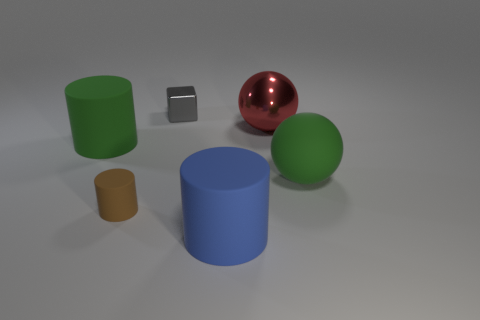Add 1 tiny gray shiny cubes. How many objects exist? 7 Subtract all blocks. How many objects are left? 5 Subtract all matte spheres. Subtract all large red metal balls. How many objects are left? 4 Add 1 brown matte things. How many brown matte things are left? 2 Add 4 large matte objects. How many large matte objects exist? 7 Subtract 0 blue blocks. How many objects are left? 6 